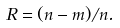Convert formula to latex. <formula><loc_0><loc_0><loc_500><loc_500>R = ( n - m ) / n .</formula> 